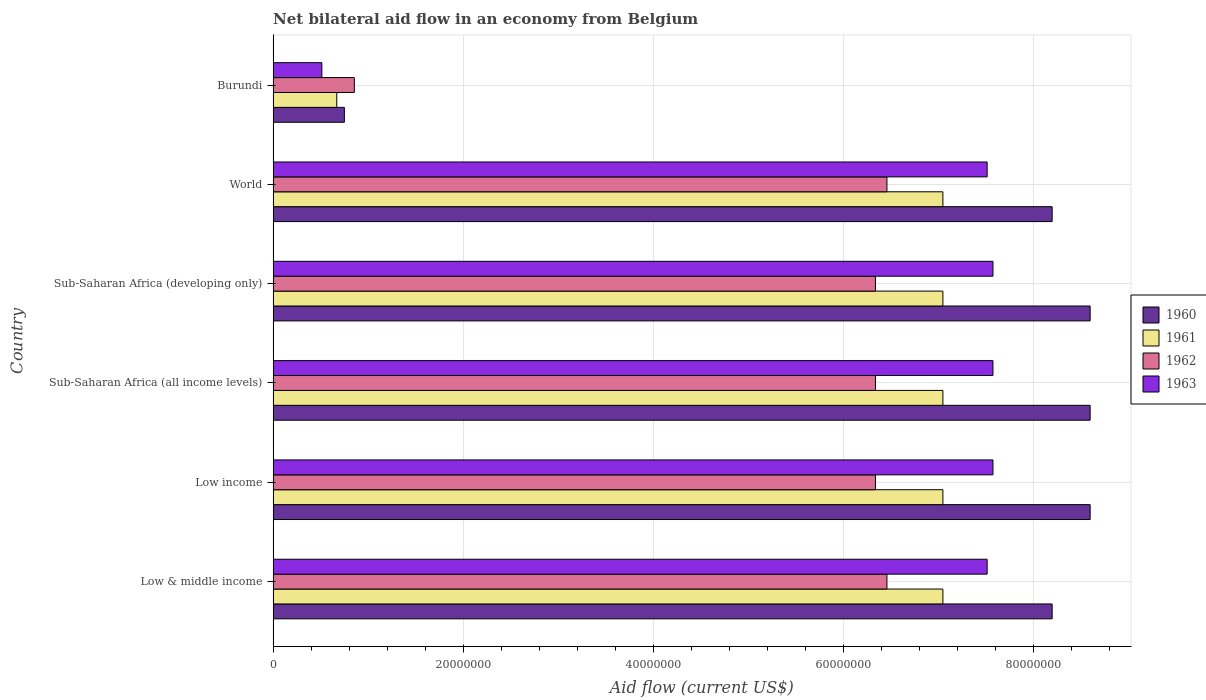How many different coloured bars are there?
Your answer should be compact. 4. How many groups of bars are there?
Your response must be concise. 6. How many bars are there on the 3rd tick from the bottom?
Give a very brief answer. 4. What is the label of the 5th group of bars from the top?
Ensure brevity in your answer.  Low income. What is the net bilateral aid flow in 1962 in Sub-Saharan Africa (developing only)?
Keep it short and to the point. 6.34e+07. Across all countries, what is the maximum net bilateral aid flow in 1960?
Keep it short and to the point. 8.60e+07. Across all countries, what is the minimum net bilateral aid flow in 1960?
Provide a succinct answer. 7.50e+06. In which country was the net bilateral aid flow in 1961 minimum?
Offer a terse response. Burundi. What is the total net bilateral aid flow in 1961 in the graph?
Your response must be concise. 3.59e+08. What is the difference between the net bilateral aid flow in 1961 in Burundi and that in World?
Provide a succinct answer. -6.38e+07. What is the difference between the net bilateral aid flow in 1961 in Sub-Saharan Africa (all income levels) and the net bilateral aid flow in 1962 in Low income?
Your answer should be very brief. 7.10e+06. What is the average net bilateral aid flow in 1960 per country?
Make the answer very short. 7.16e+07. What is the difference between the net bilateral aid flow in 1962 and net bilateral aid flow in 1963 in Sub-Saharan Africa (all income levels)?
Keep it short and to the point. -1.24e+07. What is the ratio of the net bilateral aid flow in 1960 in Burundi to that in World?
Give a very brief answer. 0.09. What is the difference between the highest and the second highest net bilateral aid flow in 1960?
Offer a terse response. 0. What is the difference between the highest and the lowest net bilateral aid flow in 1962?
Your answer should be very brief. 5.61e+07. In how many countries, is the net bilateral aid flow in 1960 greater than the average net bilateral aid flow in 1960 taken over all countries?
Offer a very short reply. 5. Is it the case that in every country, the sum of the net bilateral aid flow in 1963 and net bilateral aid flow in 1960 is greater than the sum of net bilateral aid flow in 1962 and net bilateral aid flow in 1961?
Provide a succinct answer. No. What does the 1st bar from the top in World represents?
Keep it short and to the point. 1963. Is it the case that in every country, the sum of the net bilateral aid flow in 1962 and net bilateral aid flow in 1963 is greater than the net bilateral aid flow in 1960?
Your answer should be very brief. Yes. Are all the bars in the graph horizontal?
Provide a short and direct response. Yes. How many countries are there in the graph?
Ensure brevity in your answer.  6. What is the difference between two consecutive major ticks on the X-axis?
Your answer should be very brief. 2.00e+07. Are the values on the major ticks of X-axis written in scientific E-notation?
Give a very brief answer. No. Does the graph contain any zero values?
Make the answer very short. No. Where does the legend appear in the graph?
Provide a succinct answer. Center right. How many legend labels are there?
Make the answer very short. 4. How are the legend labels stacked?
Your answer should be very brief. Vertical. What is the title of the graph?
Offer a terse response. Net bilateral aid flow in an economy from Belgium. What is the label or title of the X-axis?
Make the answer very short. Aid flow (current US$). What is the label or title of the Y-axis?
Your response must be concise. Country. What is the Aid flow (current US$) of 1960 in Low & middle income?
Make the answer very short. 8.20e+07. What is the Aid flow (current US$) in 1961 in Low & middle income?
Provide a succinct answer. 7.05e+07. What is the Aid flow (current US$) of 1962 in Low & middle income?
Provide a succinct answer. 6.46e+07. What is the Aid flow (current US$) in 1963 in Low & middle income?
Ensure brevity in your answer.  7.52e+07. What is the Aid flow (current US$) in 1960 in Low income?
Give a very brief answer. 8.60e+07. What is the Aid flow (current US$) of 1961 in Low income?
Provide a short and direct response. 7.05e+07. What is the Aid flow (current US$) of 1962 in Low income?
Your answer should be very brief. 6.34e+07. What is the Aid flow (current US$) in 1963 in Low income?
Make the answer very short. 7.58e+07. What is the Aid flow (current US$) of 1960 in Sub-Saharan Africa (all income levels)?
Offer a terse response. 8.60e+07. What is the Aid flow (current US$) of 1961 in Sub-Saharan Africa (all income levels)?
Make the answer very short. 7.05e+07. What is the Aid flow (current US$) of 1962 in Sub-Saharan Africa (all income levels)?
Make the answer very short. 6.34e+07. What is the Aid flow (current US$) of 1963 in Sub-Saharan Africa (all income levels)?
Keep it short and to the point. 7.58e+07. What is the Aid flow (current US$) of 1960 in Sub-Saharan Africa (developing only)?
Give a very brief answer. 8.60e+07. What is the Aid flow (current US$) in 1961 in Sub-Saharan Africa (developing only)?
Make the answer very short. 7.05e+07. What is the Aid flow (current US$) in 1962 in Sub-Saharan Africa (developing only)?
Give a very brief answer. 6.34e+07. What is the Aid flow (current US$) in 1963 in Sub-Saharan Africa (developing only)?
Make the answer very short. 7.58e+07. What is the Aid flow (current US$) of 1960 in World?
Offer a terse response. 8.20e+07. What is the Aid flow (current US$) of 1961 in World?
Your answer should be very brief. 7.05e+07. What is the Aid flow (current US$) in 1962 in World?
Offer a terse response. 6.46e+07. What is the Aid flow (current US$) in 1963 in World?
Ensure brevity in your answer.  7.52e+07. What is the Aid flow (current US$) in 1960 in Burundi?
Offer a terse response. 7.50e+06. What is the Aid flow (current US$) of 1961 in Burundi?
Your answer should be compact. 6.70e+06. What is the Aid flow (current US$) of 1962 in Burundi?
Keep it short and to the point. 8.55e+06. What is the Aid flow (current US$) in 1963 in Burundi?
Your answer should be compact. 5.13e+06. Across all countries, what is the maximum Aid flow (current US$) of 1960?
Offer a terse response. 8.60e+07. Across all countries, what is the maximum Aid flow (current US$) of 1961?
Provide a succinct answer. 7.05e+07. Across all countries, what is the maximum Aid flow (current US$) in 1962?
Make the answer very short. 6.46e+07. Across all countries, what is the maximum Aid flow (current US$) in 1963?
Your answer should be very brief. 7.58e+07. Across all countries, what is the minimum Aid flow (current US$) in 1960?
Your answer should be compact. 7.50e+06. Across all countries, what is the minimum Aid flow (current US$) in 1961?
Offer a terse response. 6.70e+06. Across all countries, what is the minimum Aid flow (current US$) of 1962?
Provide a short and direct response. 8.55e+06. Across all countries, what is the minimum Aid flow (current US$) in 1963?
Ensure brevity in your answer.  5.13e+06. What is the total Aid flow (current US$) in 1960 in the graph?
Offer a terse response. 4.30e+08. What is the total Aid flow (current US$) of 1961 in the graph?
Give a very brief answer. 3.59e+08. What is the total Aid flow (current US$) of 1962 in the graph?
Provide a succinct answer. 3.28e+08. What is the total Aid flow (current US$) in 1963 in the graph?
Your answer should be very brief. 3.83e+08. What is the difference between the Aid flow (current US$) in 1960 in Low & middle income and that in Low income?
Ensure brevity in your answer.  -4.00e+06. What is the difference between the Aid flow (current US$) in 1961 in Low & middle income and that in Low income?
Make the answer very short. 0. What is the difference between the Aid flow (current US$) in 1962 in Low & middle income and that in Low income?
Provide a short and direct response. 1.21e+06. What is the difference between the Aid flow (current US$) of 1963 in Low & middle income and that in Low income?
Your answer should be compact. -6.10e+05. What is the difference between the Aid flow (current US$) in 1961 in Low & middle income and that in Sub-Saharan Africa (all income levels)?
Your answer should be compact. 0. What is the difference between the Aid flow (current US$) of 1962 in Low & middle income and that in Sub-Saharan Africa (all income levels)?
Provide a succinct answer. 1.21e+06. What is the difference between the Aid flow (current US$) in 1963 in Low & middle income and that in Sub-Saharan Africa (all income levels)?
Your answer should be very brief. -6.10e+05. What is the difference between the Aid flow (current US$) of 1960 in Low & middle income and that in Sub-Saharan Africa (developing only)?
Provide a short and direct response. -4.00e+06. What is the difference between the Aid flow (current US$) in 1962 in Low & middle income and that in Sub-Saharan Africa (developing only)?
Offer a terse response. 1.21e+06. What is the difference between the Aid flow (current US$) in 1963 in Low & middle income and that in Sub-Saharan Africa (developing only)?
Provide a succinct answer. -6.10e+05. What is the difference between the Aid flow (current US$) of 1960 in Low & middle income and that in Burundi?
Keep it short and to the point. 7.45e+07. What is the difference between the Aid flow (current US$) in 1961 in Low & middle income and that in Burundi?
Give a very brief answer. 6.38e+07. What is the difference between the Aid flow (current US$) in 1962 in Low & middle income and that in Burundi?
Give a very brief answer. 5.61e+07. What is the difference between the Aid flow (current US$) of 1963 in Low & middle income and that in Burundi?
Your answer should be compact. 7.00e+07. What is the difference between the Aid flow (current US$) in 1962 in Low income and that in Sub-Saharan Africa (all income levels)?
Give a very brief answer. 0. What is the difference between the Aid flow (current US$) of 1963 in Low income and that in Sub-Saharan Africa (all income levels)?
Offer a terse response. 0. What is the difference between the Aid flow (current US$) in 1960 in Low income and that in Sub-Saharan Africa (developing only)?
Offer a very short reply. 0. What is the difference between the Aid flow (current US$) in 1961 in Low income and that in Sub-Saharan Africa (developing only)?
Your response must be concise. 0. What is the difference between the Aid flow (current US$) of 1962 in Low income and that in Sub-Saharan Africa (developing only)?
Make the answer very short. 0. What is the difference between the Aid flow (current US$) in 1961 in Low income and that in World?
Keep it short and to the point. 0. What is the difference between the Aid flow (current US$) in 1962 in Low income and that in World?
Your answer should be compact. -1.21e+06. What is the difference between the Aid flow (current US$) of 1960 in Low income and that in Burundi?
Your answer should be compact. 7.85e+07. What is the difference between the Aid flow (current US$) of 1961 in Low income and that in Burundi?
Offer a terse response. 6.38e+07. What is the difference between the Aid flow (current US$) in 1962 in Low income and that in Burundi?
Ensure brevity in your answer.  5.48e+07. What is the difference between the Aid flow (current US$) in 1963 in Low income and that in Burundi?
Ensure brevity in your answer.  7.06e+07. What is the difference between the Aid flow (current US$) of 1962 in Sub-Saharan Africa (all income levels) and that in Sub-Saharan Africa (developing only)?
Your answer should be very brief. 0. What is the difference between the Aid flow (current US$) in 1963 in Sub-Saharan Africa (all income levels) and that in Sub-Saharan Africa (developing only)?
Give a very brief answer. 0. What is the difference between the Aid flow (current US$) of 1961 in Sub-Saharan Africa (all income levels) and that in World?
Your answer should be very brief. 0. What is the difference between the Aid flow (current US$) in 1962 in Sub-Saharan Africa (all income levels) and that in World?
Offer a terse response. -1.21e+06. What is the difference between the Aid flow (current US$) of 1960 in Sub-Saharan Africa (all income levels) and that in Burundi?
Give a very brief answer. 7.85e+07. What is the difference between the Aid flow (current US$) in 1961 in Sub-Saharan Africa (all income levels) and that in Burundi?
Ensure brevity in your answer.  6.38e+07. What is the difference between the Aid flow (current US$) in 1962 in Sub-Saharan Africa (all income levels) and that in Burundi?
Provide a succinct answer. 5.48e+07. What is the difference between the Aid flow (current US$) in 1963 in Sub-Saharan Africa (all income levels) and that in Burundi?
Offer a very short reply. 7.06e+07. What is the difference between the Aid flow (current US$) in 1962 in Sub-Saharan Africa (developing only) and that in World?
Your answer should be very brief. -1.21e+06. What is the difference between the Aid flow (current US$) in 1963 in Sub-Saharan Africa (developing only) and that in World?
Keep it short and to the point. 6.10e+05. What is the difference between the Aid flow (current US$) of 1960 in Sub-Saharan Africa (developing only) and that in Burundi?
Your answer should be very brief. 7.85e+07. What is the difference between the Aid flow (current US$) in 1961 in Sub-Saharan Africa (developing only) and that in Burundi?
Keep it short and to the point. 6.38e+07. What is the difference between the Aid flow (current US$) of 1962 in Sub-Saharan Africa (developing only) and that in Burundi?
Offer a very short reply. 5.48e+07. What is the difference between the Aid flow (current US$) in 1963 in Sub-Saharan Africa (developing only) and that in Burundi?
Provide a succinct answer. 7.06e+07. What is the difference between the Aid flow (current US$) of 1960 in World and that in Burundi?
Ensure brevity in your answer.  7.45e+07. What is the difference between the Aid flow (current US$) in 1961 in World and that in Burundi?
Offer a terse response. 6.38e+07. What is the difference between the Aid flow (current US$) in 1962 in World and that in Burundi?
Offer a terse response. 5.61e+07. What is the difference between the Aid flow (current US$) in 1963 in World and that in Burundi?
Your response must be concise. 7.00e+07. What is the difference between the Aid flow (current US$) in 1960 in Low & middle income and the Aid flow (current US$) in 1961 in Low income?
Keep it short and to the point. 1.15e+07. What is the difference between the Aid flow (current US$) of 1960 in Low & middle income and the Aid flow (current US$) of 1962 in Low income?
Give a very brief answer. 1.86e+07. What is the difference between the Aid flow (current US$) in 1960 in Low & middle income and the Aid flow (current US$) in 1963 in Low income?
Provide a succinct answer. 6.23e+06. What is the difference between the Aid flow (current US$) in 1961 in Low & middle income and the Aid flow (current US$) in 1962 in Low income?
Your answer should be very brief. 7.10e+06. What is the difference between the Aid flow (current US$) of 1961 in Low & middle income and the Aid flow (current US$) of 1963 in Low income?
Provide a succinct answer. -5.27e+06. What is the difference between the Aid flow (current US$) in 1962 in Low & middle income and the Aid flow (current US$) in 1963 in Low income?
Your answer should be very brief. -1.12e+07. What is the difference between the Aid flow (current US$) in 1960 in Low & middle income and the Aid flow (current US$) in 1961 in Sub-Saharan Africa (all income levels)?
Provide a succinct answer. 1.15e+07. What is the difference between the Aid flow (current US$) in 1960 in Low & middle income and the Aid flow (current US$) in 1962 in Sub-Saharan Africa (all income levels)?
Offer a terse response. 1.86e+07. What is the difference between the Aid flow (current US$) of 1960 in Low & middle income and the Aid flow (current US$) of 1963 in Sub-Saharan Africa (all income levels)?
Give a very brief answer. 6.23e+06. What is the difference between the Aid flow (current US$) of 1961 in Low & middle income and the Aid flow (current US$) of 1962 in Sub-Saharan Africa (all income levels)?
Offer a terse response. 7.10e+06. What is the difference between the Aid flow (current US$) of 1961 in Low & middle income and the Aid flow (current US$) of 1963 in Sub-Saharan Africa (all income levels)?
Keep it short and to the point. -5.27e+06. What is the difference between the Aid flow (current US$) in 1962 in Low & middle income and the Aid flow (current US$) in 1963 in Sub-Saharan Africa (all income levels)?
Your answer should be very brief. -1.12e+07. What is the difference between the Aid flow (current US$) of 1960 in Low & middle income and the Aid flow (current US$) of 1961 in Sub-Saharan Africa (developing only)?
Your response must be concise. 1.15e+07. What is the difference between the Aid flow (current US$) in 1960 in Low & middle income and the Aid flow (current US$) in 1962 in Sub-Saharan Africa (developing only)?
Provide a short and direct response. 1.86e+07. What is the difference between the Aid flow (current US$) in 1960 in Low & middle income and the Aid flow (current US$) in 1963 in Sub-Saharan Africa (developing only)?
Ensure brevity in your answer.  6.23e+06. What is the difference between the Aid flow (current US$) in 1961 in Low & middle income and the Aid flow (current US$) in 1962 in Sub-Saharan Africa (developing only)?
Provide a short and direct response. 7.10e+06. What is the difference between the Aid flow (current US$) in 1961 in Low & middle income and the Aid flow (current US$) in 1963 in Sub-Saharan Africa (developing only)?
Keep it short and to the point. -5.27e+06. What is the difference between the Aid flow (current US$) of 1962 in Low & middle income and the Aid flow (current US$) of 1963 in Sub-Saharan Africa (developing only)?
Give a very brief answer. -1.12e+07. What is the difference between the Aid flow (current US$) of 1960 in Low & middle income and the Aid flow (current US$) of 1961 in World?
Offer a very short reply. 1.15e+07. What is the difference between the Aid flow (current US$) in 1960 in Low & middle income and the Aid flow (current US$) in 1962 in World?
Provide a succinct answer. 1.74e+07. What is the difference between the Aid flow (current US$) of 1960 in Low & middle income and the Aid flow (current US$) of 1963 in World?
Keep it short and to the point. 6.84e+06. What is the difference between the Aid flow (current US$) in 1961 in Low & middle income and the Aid flow (current US$) in 1962 in World?
Your answer should be very brief. 5.89e+06. What is the difference between the Aid flow (current US$) in 1961 in Low & middle income and the Aid flow (current US$) in 1963 in World?
Offer a very short reply. -4.66e+06. What is the difference between the Aid flow (current US$) in 1962 in Low & middle income and the Aid flow (current US$) in 1963 in World?
Your response must be concise. -1.06e+07. What is the difference between the Aid flow (current US$) of 1960 in Low & middle income and the Aid flow (current US$) of 1961 in Burundi?
Ensure brevity in your answer.  7.53e+07. What is the difference between the Aid flow (current US$) of 1960 in Low & middle income and the Aid flow (current US$) of 1962 in Burundi?
Ensure brevity in your answer.  7.34e+07. What is the difference between the Aid flow (current US$) of 1960 in Low & middle income and the Aid flow (current US$) of 1963 in Burundi?
Keep it short and to the point. 7.69e+07. What is the difference between the Aid flow (current US$) of 1961 in Low & middle income and the Aid flow (current US$) of 1962 in Burundi?
Your response must be concise. 6.20e+07. What is the difference between the Aid flow (current US$) of 1961 in Low & middle income and the Aid flow (current US$) of 1963 in Burundi?
Keep it short and to the point. 6.54e+07. What is the difference between the Aid flow (current US$) of 1962 in Low & middle income and the Aid flow (current US$) of 1963 in Burundi?
Provide a succinct answer. 5.95e+07. What is the difference between the Aid flow (current US$) in 1960 in Low income and the Aid flow (current US$) in 1961 in Sub-Saharan Africa (all income levels)?
Offer a very short reply. 1.55e+07. What is the difference between the Aid flow (current US$) in 1960 in Low income and the Aid flow (current US$) in 1962 in Sub-Saharan Africa (all income levels)?
Your answer should be very brief. 2.26e+07. What is the difference between the Aid flow (current US$) of 1960 in Low income and the Aid flow (current US$) of 1963 in Sub-Saharan Africa (all income levels)?
Offer a terse response. 1.02e+07. What is the difference between the Aid flow (current US$) of 1961 in Low income and the Aid flow (current US$) of 1962 in Sub-Saharan Africa (all income levels)?
Keep it short and to the point. 7.10e+06. What is the difference between the Aid flow (current US$) in 1961 in Low income and the Aid flow (current US$) in 1963 in Sub-Saharan Africa (all income levels)?
Provide a short and direct response. -5.27e+06. What is the difference between the Aid flow (current US$) in 1962 in Low income and the Aid flow (current US$) in 1963 in Sub-Saharan Africa (all income levels)?
Offer a terse response. -1.24e+07. What is the difference between the Aid flow (current US$) of 1960 in Low income and the Aid flow (current US$) of 1961 in Sub-Saharan Africa (developing only)?
Your response must be concise. 1.55e+07. What is the difference between the Aid flow (current US$) in 1960 in Low income and the Aid flow (current US$) in 1962 in Sub-Saharan Africa (developing only)?
Ensure brevity in your answer.  2.26e+07. What is the difference between the Aid flow (current US$) in 1960 in Low income and the Aid flow (current US$) in 1963 in Sub-Saharan Africa (developing only)?
Give a very brief answer. 1.02e+07. What is the difference between the Aid flow (current US$) in 1961 in Low income and the Aid flow (current US$) in 1962 in Sub-Saharan Africa (developing only)?
Your response must be concise. 7.10e+06. What is the difference between the Aid flow (current US$) of 1961 in Low income and the Aid flow (current US$) of 1963 in Sub-Saharan Africa (developing only)?
Offer a very short reply. -5.27e+06. What is the difference between the Aid flow (current US$) in 1962 in Low income and the Aid flow (current US$) in 1963 in Sub-Saharan Africa (developing only)?
Offer a very short reply. -1.24e+07. What is the difference between the Aid flow (current US$) of 1960 in Low income and the Aid flow (current US$) of 1961 in World?
Make the answer very short. 1.55e+07. What is the difference between the Aid flow (current US$) of 1960 in Low income and the Aid flow (current US$) of 1962 in World?
Offer a very short reply. 2.14e+07. What is the difference between the Aid flow (current US$) of 1960 in Low income and the Aid flow (current US$) of 1963 in World?
Make the answer very short. 1.08e+07. What is the difference between the Aid flow (current US$) in 1961 in Low income and the Aid flow (current US$) in 1962 in World?
Your response must be concise. 5.89e+06. What is the difference between the Aid flow (current US$) in 1961 in Low income and the Aid flow (current US$) in 1963 in World?
Your answer should be very brief. -4.66e+06. What is the difference between the Aid flow (current US$) of 1962 in Low income and the Aid flow (current US$) of 1963 in World?
Provide a succinct answer. -1.18e+07. What is the difference between the Aid flow (current US$) of 1960 in Low income and the Aid flow (current US$) of 1961 in Burundi?
Your answer should be compact. 7.93e+07. What is the difference between the Aid flow (current US$) of 1960 in Low income and the Aid flow (current US$) of 1962 in Burundi?
Provide a succinct answer. 7.74e+07. What is the difference between the Aid flow (current US$) of 1960 in Low income and the Aid flow (current US$) of 1963 in Burundi?
Offer a very short reply. 8.09e+07. What is the difference between the Aid flow (current US$) in 1961 in Low income and the Aid flow (current US$) in 1962 in Burundi?
Give a very brief answer. 6.20e+07. What is the difference between the Aid flow (current US$) in 1961 in Low income and the Aid flow (current US$) in 1963 in Burundi?
Keep it short and to the point. 6.54e+07. What is the difference between the Aid flow (current US$) in 1962 in Low income and the Aid flow (current US$) in 1963 in Burundi?
Ensure brevity in your answer.  5.83e+07. What is the difference between the Aid flow (current US$) of 1960 in Sub-Saharan Africa (all income levels) and the Aid flow (current US$) of 1961 in Sub-Saharan Africa (developing only)?
Offer a very short reply. 1.55e+07. What is the difference between the Aid flow (current US$) in 1960 in Sub-Saharan Africa (all income levels) and the Aid flow (current US$) in 1962 in Sub-Saharan Africa (developing only)?
Your answer should be very brief. 2.26e+07. What is the difference between the Aid flow (current US$) of 1960 in Sub-Saharan Africa (all income levels) and the Aid flow (current US$) of 1963 in Sub-Saharan Africa (developing only)?
Give a very brief answer. 1.02e+07. What is the difference between the Aid flow (current US$) in 1961 in Sub-Saharan Africa (all income levels) and the Aid flow (current US$) in 1962 in Sub-Saharan Africa (developing only)?
Your answer should be very brief. 7.10e+06. What is the difference between the Aid flow (current US$) in 1961 in Sub-Saharan Africa (all income levels) and the Aid flow (current US$) in 1963 in Sub-Saharan Africa (developing only)?
Keep it short and to the point. -5.27e+06. What is the difference between the Aid flow (current US$) of 1962 in Sub-Saharan Africa (all income levels) and the Aid flow (current US$) of 1963 in Sub-Saharan Africa (developing only)?
Your response must be concise. -1.24e+07. What is the difference between the Aid flow (current US$) in 1960 in Sub-Saharan Africa (all income levels) and the Aid flow (current US$) in 1961 in World?
Your answer should be very brief. 1.55e+07. What is the difference between the Aid flow (current US$) in 1960 in Sub-Saharan Africa (all income levels) and the Aid flow (current US$) in 1962 in World?
Keep it short and to the point. 2.14e+07. What is the difference between the Aid flow (current US$) of 1960 in Sub-Saharan Africa (all income levels) and the Aid flow (current US$) of 1963 in World?
Provide a short and direct response. 1.08e+07. What is the difference between the Aid flow (current US$) of 1961 in Sub-Saharan Africa (all income levels) and the Aid flow (current US$) of 1962 in World?
Offer a terse response. 5.89e+06. What is the difference between the Aid flow (current US$) of 1961 in Sub-Saharan Africa (all income levels) and the Aid flow (current US$) of 1963 in World?
Your response must be concise. -4.66e+06. What is the difference between the Aid flow (current US$) of 1962 in Sub-Saharan Africa (all income levels) and the Aid flow (current US$) of 1963 in World?
Provide a short and direct response. -1.18e+07. What is the difference between the Aid flow (current US$) of 1960 in Sub-Saharan Africa (all income levels) and the Aid flow (current US$) of 1961 in Burundi?
Make the answer very short. 7.93e+07. What is the difference between the Aid flow (current US$) of 1960 in Sub-Saharan Africa (all income levels) and the Aid flow (current US$) of 1962 in Burundi?
Provide a short and direct response. 7.74e+07. What is the difference between the Aid flow (current US$) of 1960 in Sub-Saharan Africa (all income levels) and the Aid flow (current US$) of 1963 in Burundi?
Make the answer very short. 8.09e+07. What is the difference between the Aid flow (current US$) in 1961 in Sub-Saharan Africa (all income levels) and the Aid flow (current US$) in 1962 in Burundi?
Ensure brevity in your answer.  6.20e+07. What is the difference between the Aid flow (current US$) in 1961 in Sub-Saharan Africa (all income levels) and the Aid flow (current US$) in 1963 in Burundi?
Offer a terse response. 6.54e+07. What is the difference between the Aid flow (current US$) of 1962 in Sub-Saharan Africa (all income levels) and the Aid flow (current US$) of 1963 in Burundi?
Make the answer very short. 5.83e+07. What is the difference between the Aid flow (current US$) of 1960 in Sub-Saharan Africa (developing only) and the Aid flow (current US$) of 1961 in World?
Give a very brief answer. 1.55e+07. What is the difference between the Aid flow (current US$) in 1960 in Sub-Saharan Africa (developing only) and the Aid flow (current US$) in 1962 in World?
Make the answer very short. 2.14e+07. What is the difference between the Aid flow (current US$) in 1960 in Sub-Saharan Africa (developing only) and the Aid flow (current US$) in 1963 in World?
Ensure brevity in your answer.  1.08e+07. What is the difference between the Aid flow (current US$) in 1961 in Sub-Saharan Africa (developing only) and the Aid flow (current US$) in 1962 in World?
Make the answer very short. 5.89e+06. What is the difference between the Aid flow (current US$) in 1961 in Sub-Saharan Africa (developing only) and the Aid flow (current US$) in 1963 in World?
Make the answer very short. -4.66e+06. What is the difference between the Aid flow (current US$) in 1962 in Sub-Saharan Africa (developing only) and the Aid flow (current US$) in 1963 in World?
Keep it short and to the point. -1.18e+07. What is the difference between the Aid flow (current US$) of 1960 in Sub-Saharan Africa (developing only) and the Aid flow (current US$) of 1961 in Burundi?
Offer a terse response. 7.93e+07. What is the difference between the Aid flow (current US$) of 1960 in Sub-Saharan Africa (developing only) and the Aid flow (current US$) of 1962 in Burundi?
Your answer should be very brief. 7.74e+07. What is the difference between the Aid flow (current US$) of 1960 in Sub-Saharan Africa (developing only) and the Aid flow (current US$) of 1963 in Burundi?
Make the answer very short. 8.09e+07. What is the difference between the Aid flow (current US$) in 1961 in Sub-Saharan Africa (developing only) and the Aid flow (current US$) in 1962 in Burundi?
Give a very brief answer. 6.20e+07. What is the difference between the Aid flow (current US$) in 1961 in Sub-Saharan Africa (developing only) and the Aid flow (current US$) in 1963 in Burundi?
Offer a terse response. 6.54e+07. What is the difference between the Aid flow (current US$) in 1962 in Sub-Saharan Africa (developing only) and the Aid flow (current US$) in 1963 in Burundi?
Make the answer very short. 5.83e+07. What is the difference between the Aid flow (current US$) in 1960 in World and the Aid flow (current US$) in 1961 in Burundi?
Offer a terse response. 7.53e+07. What is the difference between the Aid flow (current US$) of 1960 in World and the Aid flow (current US$) of 1962 in Burundi?
Provide a succinct answer. 7.34e+07. What is the difference between the Aid flow (current US$) in 1960 in World and the Aid flow (current US$) in 1963 in Burundi?
Your answer should be very brief. 7.69e+07. What is the difference between the Aid flow (current US$) of 1961 in World and the Aid flow (current US$) of 1962 in Burundi?
Your response must be concise. 6.20e+07. What is the difference between the Aid flow (current US$) in 1961 in World and the Aid flow (current US$) in 1963 in Burundi?
Give a very brief answer. 6.54e+07. What is the difference between the Aid flow (current US$) in 1962 in World and the Aid flow (current US$) in 1963 in Burundi?
Your answer should be very brief. 5.95e+07. What is the average Aid flow (current US$) of 1960 per country?
Make the answer very short. 7.16e+07. What is the average Aid flow (current US$) of 1961 per country?
Keep it short and to the point. 5.99e+07. What is the average Aid flow (current US$) in 1962 per country?
Provide a short and direct response. 5.47e+07. What is the average Aid flow (current US$) in 1963 per country?
Offer a very short reply. 6.38e+07. What is the difference between the Aid flow (current US$) in 1960 and Aid flow (current US$) in 1961 in Low & middle income?
Your response must be concise. 1.15e+07. What is the difference between the Aid flow (current US$) of 1960 and Aid flow (current US$) of 1962 in Low & middle income?
Offer a very short reply. 1.74e+07. What is the difference between the Aid flow (current US$) in 1960 and Aid flow (current US$) in 1963 in Low & middle income?
Give a very brief answer. 6.84e+06. What is the difference between the Aid flow (current US$) of 1961 and Aid flow (current US$) of 1962 in Low & middle income?
Make the answer very short. 5.89e+06. What is the difference between the Aid flow (current US$) of 1961 and Aid flow (current US$) of 1963 in Low & middle income?
Make the answer very short. -4.66e+06. What is the difference between the Aid flow (current US$) in 1962 and Aid flow (current US$) in 1963 in Low & middle income?
Keep it short and to the point. -1.06e+07. What is the difference between the Aid flow (current US$) of 1960 and Aid flow (current US$) of 1961 in Low income?
Give a very brief answer. 1.55e+07. What is the difference between the Aid flow (current US$) of 1960 and Aid flow (current US$) of 1962 in Low income?
Offer a terse response. 2.26e+07. What is the difference between the Aid flow (current US$) of 1960 and Aid flow (current US$) of 1963 in Low income?
Give a very brief answer. 1.02e+07. What is the difference between the Aid flow (current US$) in 1961 and Aid flow (current US$) in 1962 in Low income?
Your response must be concise. 7.10e+06. What is the difference between the Aid flow (current US$) in 1961 and Aid flow (current US$) in 1963 in Low income?
Provide a succinct answer. -5.27e+06. What is the difference between the Aid flow (current US$) in 1962 and Aid flow (current US$) in 1963 in Low income?
Your answer should be very brief. -1.24e+07. What is the difference between the Aid flow (current US$) of 1960 and Aid flow (current US$) of 1961 in Sub-Saharan Africa (all income levels)?
Your answer should be very brief. 1.55e+07. What is the difference between the Aid flow (current US$) of 1960 and Aid flow (current US$) of 1962 in Sub-Saharan Africa (all income levels)?
Make the answer very short. 2.26e+07. What is the difference between the Aid flow (current US$) in 1960 and Aid flow (current US$) in 1963 in Sub-Saharan Africa (all income levels)?
Your answer should be compact. 1.02e+07. What is the difference between the Aid flow (current US$) of 1961 and Aid flow (current US$) of 1962 in Sub-Saharan Africa (all income levels)?
Your answer should be very brief. 7.10e+06. What is the difference between the Aid flow (current US$) of 1961 and Aid flow (current US$) of 1963 in Sub-Saharan Africa (all income levels)?
Ensure brevity in your answer.  -5.27e+06. What is the difference between the Aid flow (current US$) of 1962 and Aid flow (current US$) of 1963 in Sub-Saharan Africa (all income levels)?
Provide a short and direct response. -1.24e+07. What is the difference between the Aid flow (current US$) of 1960 and Aid flow (current US$) of 1961 in Sub-Saharan Africa (developing only)?
Your answer should be compact. 1.55e+07. What is the difference between the Aid flow (current US$) of 1960 and Aid flow (current US$) of 1962 in Sub-Saharan Africa (developing only)?
Offer a terse response. 2.26e+07. What is the difference between the Aid flow (current US$) of 1960 and Aid flow (current US$) of 1963 in Sub-Saharan Africa (developing only)?
Your answer should be compact. 1.02e+07. What is the difference between the Aid flow (current US$) in 1961 and Aid flow (current US$) in 1962 in Sub-Saharan Africa (developing only)?
Keep it short and to the point. 7.10e+06. What is the difference between the Aid flow (current US$) in 1961 and Aid flow (current US$) in 1963 in Sub-Saharan Africa (developing only)?
Provide a succinct answer. -5.27e+06. What is the difference between the Aid flow (current US$) in 1962 and Aid flow (current US$) in 1963 in Sub-Saharan Africa (developing only)?
Make the answer very short. -1.24e+07. What is the difference between the Aid flow (current US$) in 1960 and Aid flow (current US$) in 1961 in World?
Ensure brevity in your answer.  1.15e+07. What is the difference between the Aid flow (current US$) in 1960 and Aid flow (current US$) in 1962 in World?
Provide a short and direct response. 1.74e+07. What is the difference between the Aid flow (current US$) in 1960 and Aid flow (current US$) in 1963 in World?
Offer a very short reply. 6.84e+06. What is the difference between the Aid flow (current US$) of 1961 and Aid flow (current US$) of 1962 in World?
Keep it short and to the point. 5.89e+06. What is the difference between the Aid flow (current US$) in 1961 and Aid flow (current US$) in 1963 in World?
Your answer should be compact. -4.66e+06. What is the difference between the Aid flow (current US$) of 1962 and Aid flow (current US$) of 1963 in World?
Ensure brevity in your answer.  -1.06e+07. What is the difference between the Aid flow (current US$) in 1960 and Aid flow (current US$) in 1961 in Burundi?
Offer a very short reply. 8.00e+05. What is the difference between the Aid flow (current US$) of 1960 and Aid flow (current US$) of 1962 in Burundi?
Your answer should be very brief. -1.05e+06. What is the difference between the Aid flow (current US$) of 1960 and Aid flow (current US$) of 1963 in Burundi?
Provide a short and direct response. 2.37e+06. What is the difference between the Aid flow (current US$) in 1961 and Aid flow (current US$) in 1962 in Burundi?
Provide a short and direct response. -1.85e+06. What is the difference between the Aid flow (current US$) in 1961 and Aid flow (current US$) in 1963 in Burundi?
Your response must be concise. 1.57e+06. What is the difference between the Aid flow (current US$) in 1962 and Aid flow (current US$) in 1963 in Burundi?
Your answer should be compact. 3.42e+06. What is the ratio of the Aid flow (current US$) in 1960 in Low & middle income to that in Low income?
Ensure brevity in your answer.  0.95. What is the ratio of the Aid flow (current US$) of 1961 in Low & middle income to that in Low income?
Give a very brief answer. 1. What is the ratio of the Aid flow (current US$) in 1962 in Low & middle income to that in Low income?
Give a very brief answer. 1.02. What is the ratio of the Aid flow (current US$) in 1960 in Low & middle income to that in Sub-Saharan Africa (all income levels)?
Your answer should be compact. 0.95. What is the ratio of the Aid flow (current US$) in 1962 in Low & middle income to that in Sub-Saharan Africa (all income levels)?
Your response must be concise. 1.02. What is the ratio of the Aid flow (current US$) in 1960 in Low & middle income to that in Sub-Saharan Africa (developing only)?
Provide a short and direct response. 0.95. What is the ratio of the Aid flow (current US$) in 1962 in Low & middle income to that in Sub-Saharan Africa (developing only)?
Give a very brief answer. 1.02. What is the ratio of the Aid flow (current US$) in 1963 in Low & middle income to that in Sub-Saharan Africa (developing only)?
Your answer should be compact. 0.99. What is the ratio of the Aid flow (current US$) of 1961 in Low & middle income to that in World?
Offer a very short reply. 1. What is the ratio of the Aid flow (current US$) in 1960 in Low & middle income to that in Burundi?
Keep it short and to the point. 10.93. What is the ratio of the Aid flow (current US$) of 1961 in Low & middle income to that in Burundi?
Your answer should be very brief. 10.52. What is the ratio of the Aid flow (current US$) of 1962 in Low & middle income to that in Burundi?
Ensure brevity in your answer.  7.56. What is the ratio of the Aid flow (current US$) in 1963 in Low & middle income to that in Burundi?
Make the answer very short. 14.65. What is the ratio of the Aid flow (current US$) of 1961 in Low income to that in Sub-Saharan Africa (all income levels)?
Provide a succinct answer. 1. What is the ratio of the Aid flow (current US$) in 1961 in Low income to that in Sub-Saharan Africa (developing only)?
Offer a very short reply. 1. What is the ratio of the Aid flow (current US$) of 1960 in Low income to that in World?
Provide a short and direct response. 1.05. What is the ratio of the Aid flow (current US$) in 1962 in Low income to that in World?
Your answer should be compact. 0.98. What is the ratio of the Aid flow (current US$) of 1960 in Low income to that in Burundi?
Your answer should be very brief. 11.47. What is the ratio of the Aid flow (current US$) in 1961 in Low income to that in Burundi?
Offer a terse response. 10.52. What is the ratio of the Aid flow (current US$) in 1962 in Low income to that in Burundi?
Give a very brief answer. 7.42. What is the ratio of the Aid flow (current US$) of 1963 in Low income to that in Burundi?
Keep it short and to the point. 14.77. What is the ratio of the Aid flow (current US$) of 1961 in Sub-Saharan Africa (all income levels) to that in Sub-Saharan Africa (developing only)?
Ensure brevity in your answer.  1. What is the ratio of the Aid flow (current US$) of 1962 in Sub-Saharan Africa (all income levels) to that in Sub-Saharan Africa (developing only)?
Your answer should be very brief. 1. What is the ratio of the Aid flow (current US$) in 1963 in Sub-Saharan Africa (all income levels) to that in Sub-Saharan Africa (developing only)?
Offer a very short reply. 1. What is the ratio of the Aid flow (current US$) in 1960 in Sub-Saharan Africa (all income levels) to that in World?
Provide a succinct answer. 1.05. What is the ratio of the Aid flow (current US$) of 1962 in Sub-Saharan Africa (all income levels) to that in World?
Give a very brief answer. 0.98. What is the ratio of the Aid flow (current US$) of 1963 in Sub-Saharan Africa (all income levels) to that in World?
Give a very brief answer. 1.01. What is the ratio of the Aid flow (current US$) in 1960 in Sub-Saharan Africa (all income levels) to that in Burundi?
Your answer should be compact. 11.47. What is the ratio of the Aid flow (current US$) of 1961 in Sub-Saharan Africa (all income levels) to that in Burundi?
Give a very brief answer. 10.52. What is the ratio of the Aid flow (current US$) in 1962 in Sub-Saharan Africa (all income levels) to that in Burundi?
Your answer should be very brief. 7.42. What is the ratio of the Aid flow (current US$) in 1963 in Sub-Saharan Africa (all income levels) to that in Burundi?
Your answer should be compact. 14.77. What is the ratio of the Aid flow (current US$) of 1960 in Sub-Saharan Africa (developing only) to that in World?
Your response must be concise. 1.05. What is the ratio of the Aid flow (current US$) in 1962 in Sub-Saharan Africa (developing only) to that in World?
Ensure brevity in your answer.  0.98. What is the ratio of the Aid flow (current US$) in 1963 in Sub-Saharan Africa (developing only) to that in World?
Your answer should be compact. 1.01. What is the ratio of the Aid flow (current US$) in 1960 in Sub-Saharan Africa (developing only) to that in Burundi?
Make the answer very short. 11.47. What is the ratio of the Aid flow (current US$) of 1961 in Sub-Saharan Africa (developing only) to that in Burundi?
Offer a very short reply. 10.52. What is the ratio of the Aid flow (current US$) in 1962 in Sub-Saharan Africa (developing only) to that in Burundi?
Offer a terse response. 7.42. What is the ratio of the Aid flow (current US$) of 1963 in Sub-Saharan Africa (developing only) to that in Burundi?
Your answer should be compact. 14.77. What is the ratio of the Aid flow (current US$) in 1960 in World to that in Burundi?
Your answer should be compact. 10.93. What is the ratio of the Aid flow (current US$) in 1961 in World to that in Burundi?
Your answer should be compact. 10.52. What is the ratio of the Aid flow (current US$) of 1962 in World to that in Burundi?
Provide a succinct answer. 7.56. What is the ratio of the Aid flow (current US$) in 1963 in World to that in Burundi?
Offer a very short reply. 14.65. What is the difference between the highest and the lowest Aid flow (current US$) in 1960?
Your answer should be compact. 7.85e+07. What is the difference between the highest and the lowest Aid flow (current US$) of 1961?
Keep it short and to the point. 6.38e+07. What is the difference between the highest and the lowest Aid flow (current US$) of 1962?
Offer a very short reply. 5.61e+07. What is the difference between the highest and the lowest Aid flow (current US$) of 1963?
Your response must be concise. 7.06e+07. 